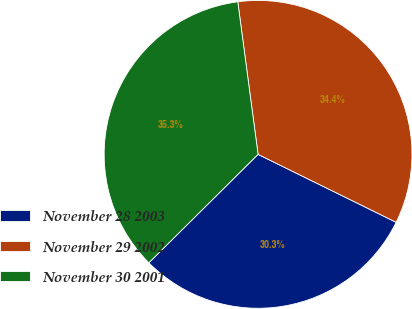Convert chart to OTSL. <chart><loc_0><loc_0><loc_500><loc_500><pie_chart><fcel>November 28 2003<fcel>November 29 2002<fcel>November 30 2001<nl><fcel>30.28%<fcel>34.38%<fcel>35.34%<nl></chart> 